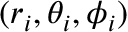<formula> <loc_0><loc_0><loc_500><loc_500>( r _ { i } , \theta _ { i } , \phi _ { i } )</formula> 